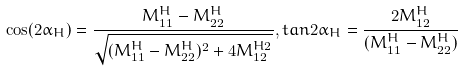<formula> <loc_0><loc_0><loc_500><loc_500>\cos ( 2 \alpha _ { H } ) = \frac { M ^ { H } _ { 1 1 } - M ^ { H } _ { 2 2 } } { \sqrt { ( M ^ { H } _ { 1 1 } - M ^ { H } _ { 2 2 } ) ^ { 2 } + 4 M ^ { H 2 } _ { 1 2 } } } , t a n 2 \alpha _ { H } = \frac { 2 M ^ { H } _ { 1 2 } } { ( M ^ { H } _ { 1 1 } - M ^ { H } _ { 2 2 } ) }</formula> 